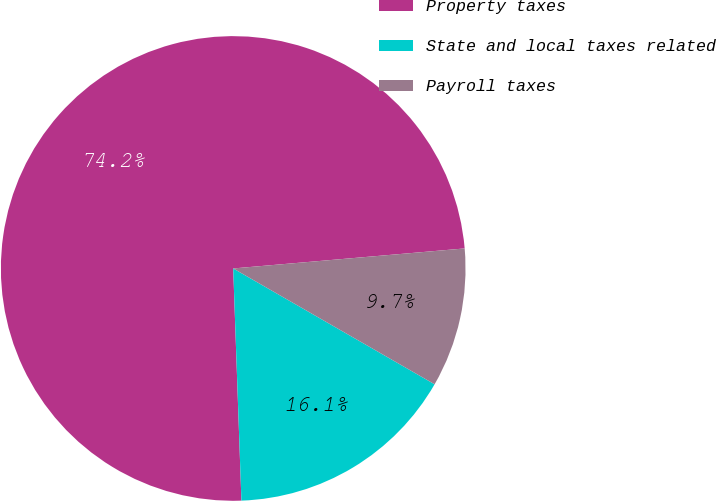<chart> <loc_0><loc_0><loc_500><loc_500><pie_chart><fcel>Property taxes<fcel>State and local taxes related<fcel>Payroll taxes<nl><fcel>74.19%<fcel>16.13%<fcel>9.68%<nl></chart> 